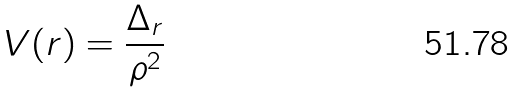<formula> <loc_0><loc_0><loc_500><loc_500>V ( r ) = \frac { \Delta _ { r } } { \rho ^ { 2 } }</formula> 